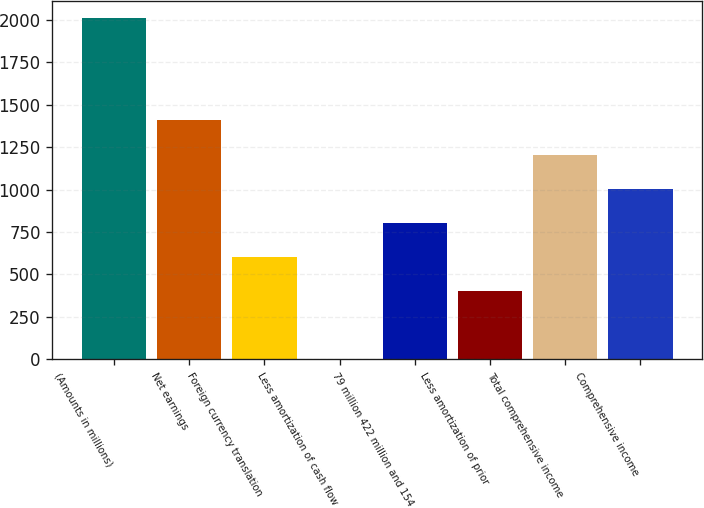Convert chart to OTSL. <chart><loc_0><loc_0><loc_500><loc_500><bar_chart><fcel>(Amounts in millions)<fcel>Net earnings<fcel>Foreign currency translation<fcel>Less amortization of cash flow<fcel>79 million 422 million and 154<fcel>Less amortization of prior<fcel>Total comprehensive income<fcel>Comprehensive income<nl><fcel>2010<fcel>1407.03<fcel>603.07<fcel>0.1<fcel>804.06<fcel>402.08<fcel>1206.04<fcel>1005.05<nl></chart> 